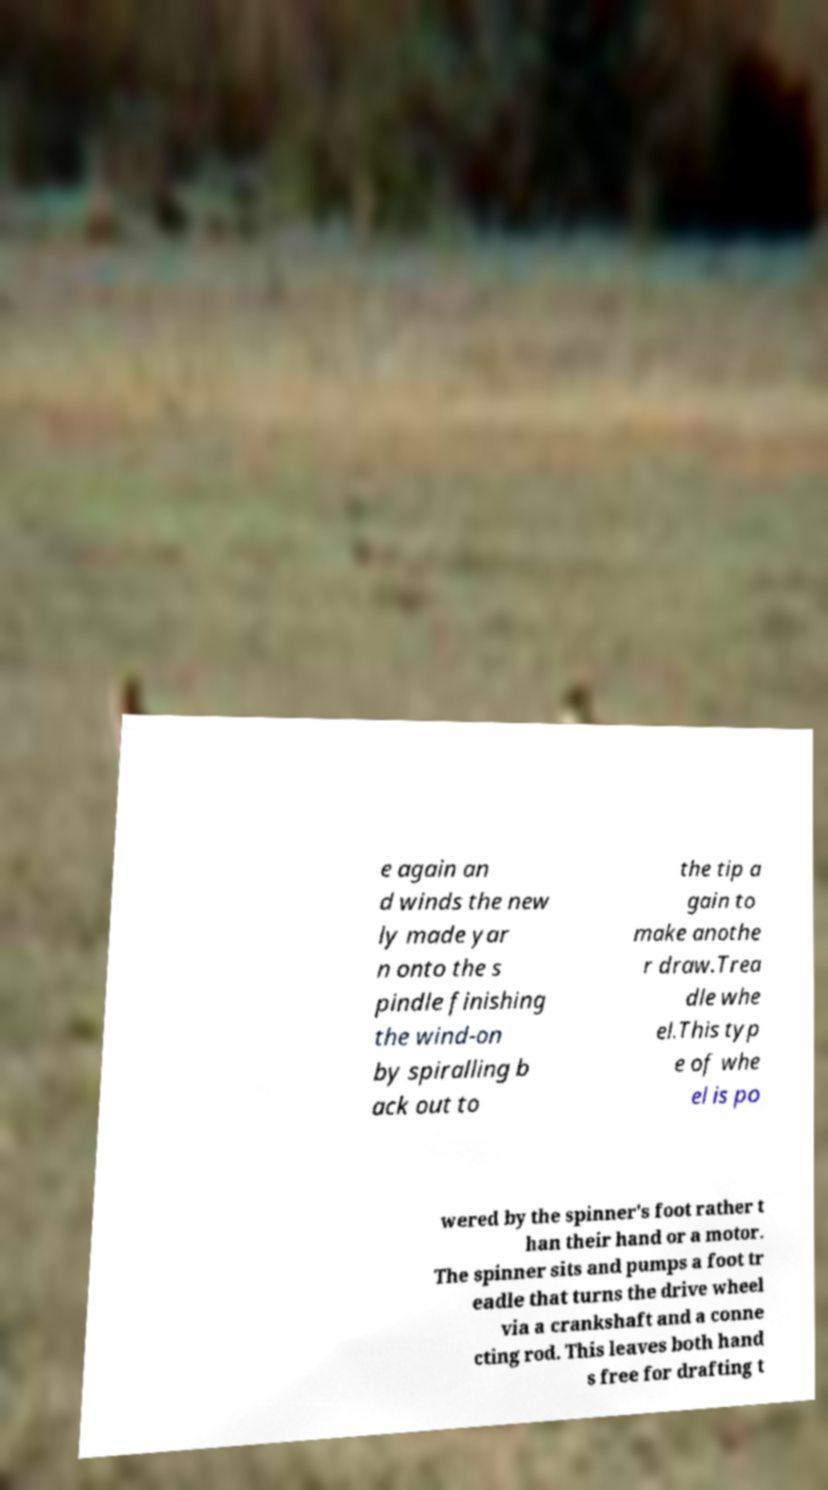Please read and relay the text visible in this image. What does it say? e again an d winds the new ly made yar n onto the s pindle finishing the wind-on by spiralling b ack out to the tip a gain to make anothe r draw.Trea dle whe el.This typ e of whe el is po wered by the spinner's foot rather t han their hand or a motor. The spinner sits and pumps a foot tr eadle that turns the drive wheel via a crankshaft and a conne cting rod. This leaves both hand s free for drafting t 